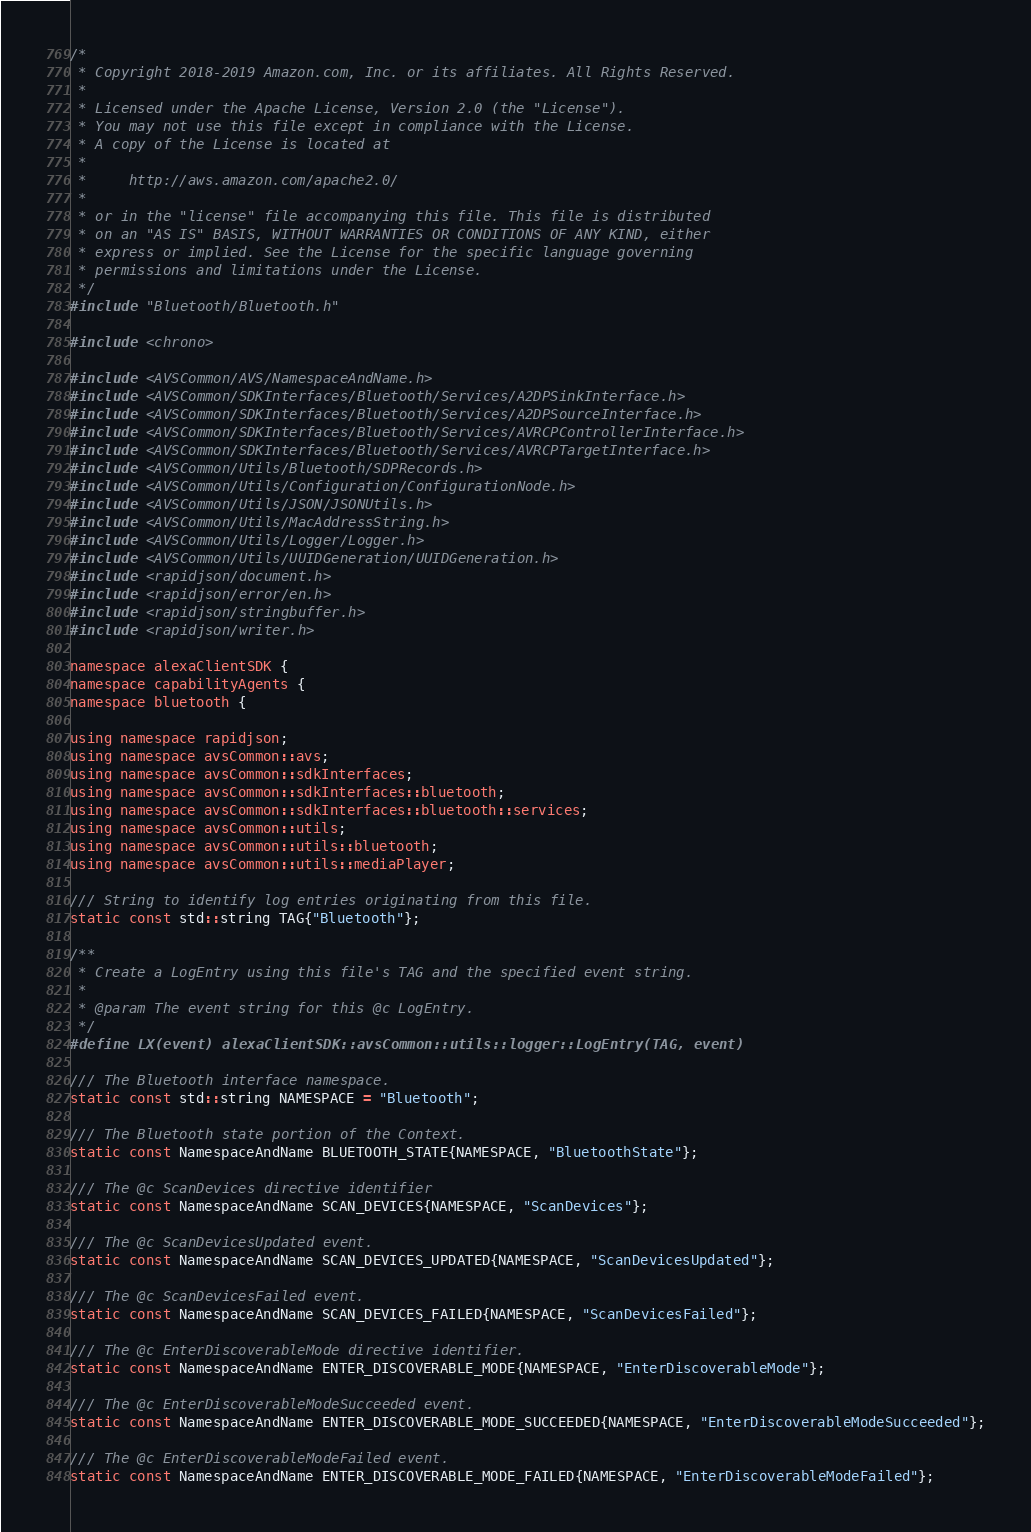<code> <loc_0><loc_0><loc_500><loc_500><_C++_>/*
 * Copyright 2018-2019 Amazon.com, Inc. or its affiliates. All Rights Reserved.
 *
 * Licensed under the Apache License, Version 2.0 (the "License").
 * You may not use this file except in compliance with the License.
 * A copy of the License is located at
 *
 *     http://aws.amazon.com/apache2.0/
 *
 * or in the "license" file accompanying this file. This file is distributed
 * on an "AS IS" BASIS, WITHOUT WARRANTIES OR CONDITIONS OF ANY KIND, either
 * express or implied. See the License for the specific language governing
 * permissions and limitations under the License.
 */
#include "Bluetooth/Bluetooth.h"

#include <chrono>

#include <AVSCommon/AVS/NamespaceAndName.h>
#include <AVSCommon/SDKInterfaces/Bluetooth/Services/A2DPSinkInterface.h>
#include <AVSCommon/SDKInterfaces/Bluetooth/Services/A2DPSourceInterface.h>
#include <AVSCommon/SDKInterfaces/Bluetooth/Services/AVRCPControllerInterface.h>
#include <AVSCommon/SDKInterfaces/Bluetooth/Services/AVRCPTargetInterface.h>
#include <AVSCommon/Utils/Bluetooth/SDPRecords.h>
#include <AVSCommon/Utils/Configuration/ConfigurationNode.h>
#include <AVSCommon/Utils/JSON/JSONUtils.h>
#include <AVSCommon/Utils/MacAddressString.h>
#include <AVSCommon/Utils/Logger/Logger.h>
#include <AVSCommon/Utils/UUIDGeneration/UUIDGeneration.h>
#include <rapidjson/document.h>
#include <rapidjson/error/en.h>
#include <rapidjson/stringbuffer.h>
#include <rapidjson/writer.h>

namespace alexaClientSDK {
namespace capabilityAgents {
namespace bluetooth {

using namespace rapidjson;
using namespace avsCommon::avs;
using namespace avsCommon::sdkInterfaces;
using namespace avsCommon::sdkInterfaces::bluetooth;
using namespace avsCommon::sdkInterfaces::bluetooth::services;
using namespace avsCommon::utils;
using namespace avsCommon::utils::bluetooth;
using namespace avsCommon::utils::mediaPlayer;

/// String to identify log entries originating from this file.
static const std::string TAG{"Bluetooth"};

/**
 * Create a LogEntry using this file's TAG and the specified event string.
 *
 * @param The event string for this @c LogEntry.
 */
#define LX(event) alexaClientSDK::avsCommon::utils::logger::LogEntry(TAG, event)

/// The Bluetooth interface namespace.
static const std::string NAMESPACE = "Bluetooth";

/// The Bluetooth state portion of the Context.
static const NamespaceAndName BLUETOOTH_STATE{NAMESPACE, "BluetoothState"};

/// The @c ScanDevices directive identifier
static const NamespaceAndName SCAN_DEVICES{NAMESPACE, "ScanDevices"};

/// The @c ScanDevicesUpdated event.
static const NamespaceAndName SCAN_DEVICES_UPDATED{NAMESPACE, "ScanDevicesUpdated"};

/// The @c ScanDevicesFailed event.
static const NamespaceAndName SCAN_DEVICES_FAILED{NAMESPACE, "ScanDevicesFailed"};

/// The @c EnterDiscoverableMode directive identifier.
static const NamespaceAndName ENTER_DISCOVERABLE_MODE{NAMESPACE, "EnterDiscoverableMode"};

/// The @c EnterDiscoverableModeSucceeded event.
static const NamespaceAndName ENTER_DISCOVERABLE_MODE_SUCCEEDED{NAMESPACE, "EnterDiscoverableModeSucceeded"};

/// The @c EnterDiscoverableModeFailed event.
static const NamespaceAndName ENTER_DISCOVERABLE_MODE_FAILED{NAMESPACE, "EnterDiscoverableModeFailed"};
</code> 